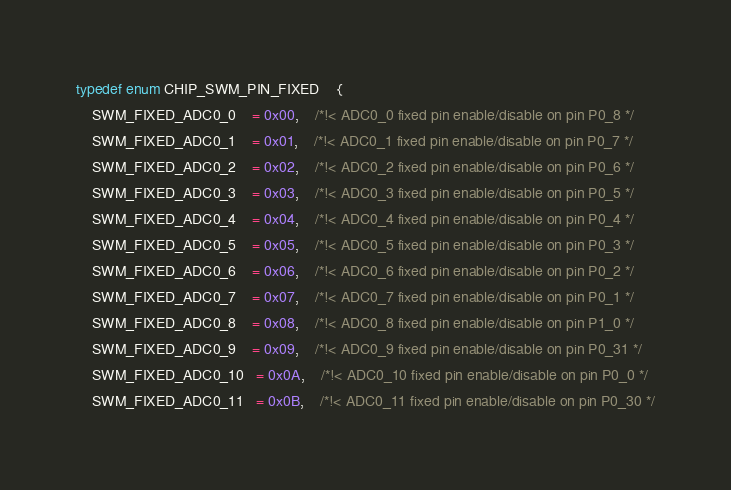Convert code to text. <code><loc_0><loc_0><loc_500><loc_500><_C_>typedef enum CHIP_SWM_PIN_FIXED    {
	SWM_FIXED_ADC0_0    = 0x00,	/*!< ADC0_0 fixed pin enable/disable on pin P0_8 */
	SWM_FIXED_ADC0_1    = 0x01,	/*!< ADC0_1 fixed pin enable/disable on pin P0_7 */
	SWM_FIXED_ADC0_2    = 0x02,	/*!< ADC0_2 fixed pin enable/disable on pin P0_6 */
	SWM_FIXED_ADC0_3    = 0x03,	/*!< ADC0_3 fixed pin enable/disable on pin P0_5 */
	SWM_FIXED_ADC0_4    = 0x04,	/*!< ADC0_4 fixed pin enable/disable on pin P0_4 */
	SWM_FIXED_ADC0_5    = 0x05,	/*!< ADC0_5 fixed pin enable/disable on pin P0_3 */
	SWM_FIXED_ADC0_6    = 0x06,	/*!< ADC0_6 fixed pin enable/disable on pin P0_2 */
	SWM_FIXED_ADC0_7    = 0x07,	/*!< ADC0_7 fixed pin enable/disable on pin P0_1 */
	SWM_FIXED_ADC0_8    = 0x08,	/*!< ADC0_8 fixed pin enable/disable on pin P1_0 */
	SWM_FIXED_ADC0_9    = 0x09,	/*!< ADC0_9 fixed pin enable/disable on pin P0_31 */
	SWM_FIXED_ADC0_10   = 0x0A,	/*!< ADC0_10 fixed pin enable/disable on pin P0_0 */
	SWM_FIXED_ADC0_11   = 0x0B,	/*!< ADC0_11 fixed pin enable/disable on pin P0_30 */</code> 